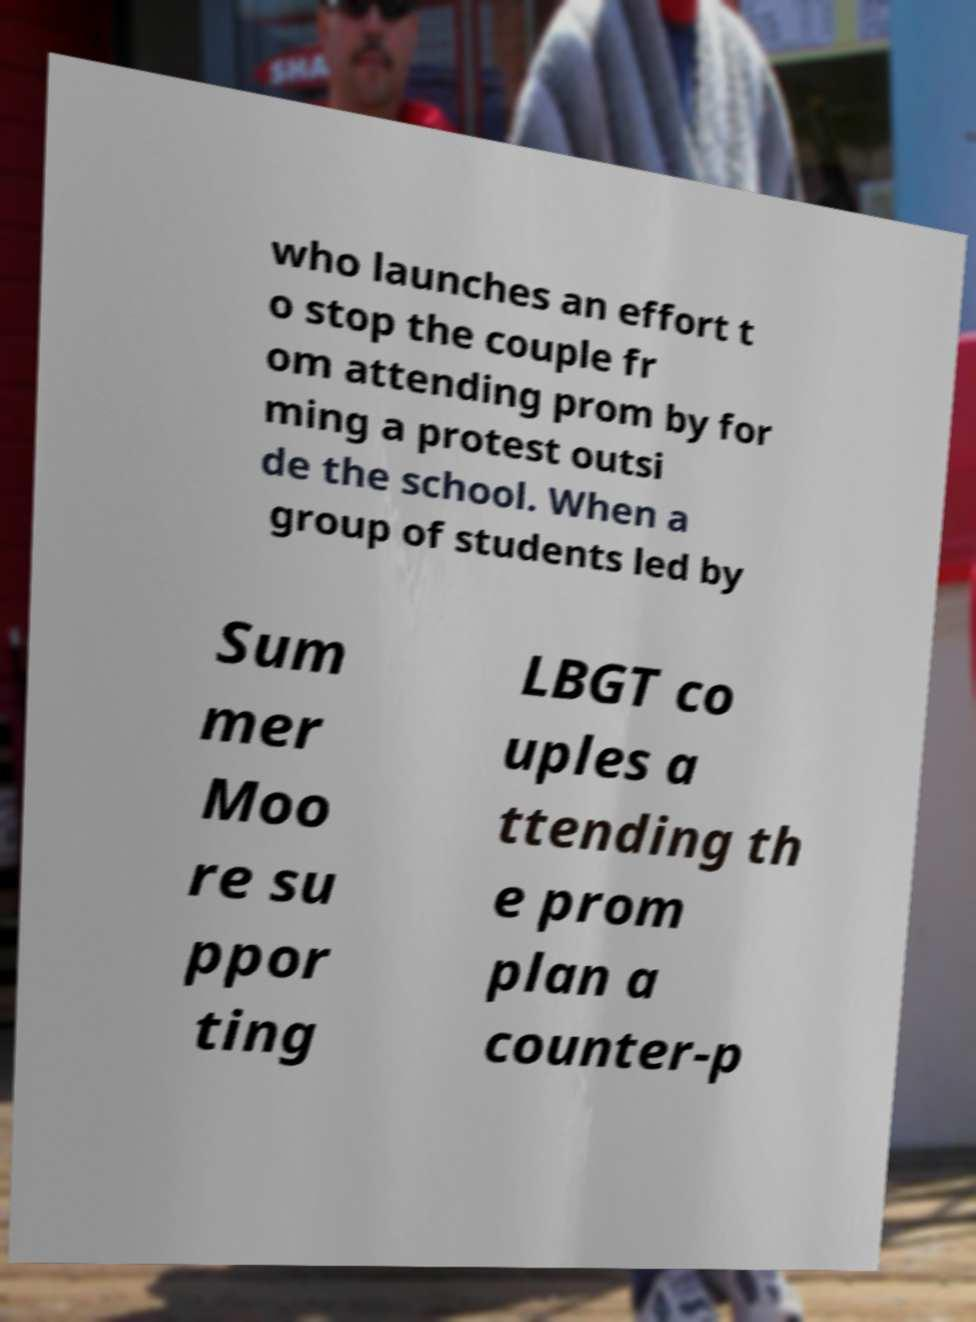What messages or text are displayed in this image? I need them in a readable, typed format. who launches an effort t o stop the couple fr om attending prom by for ming a protest outsi de the school. When a group of students led by Sum mer Moo re su ppor ting LBGT co uples a ttending th e prom plan a counter-p 